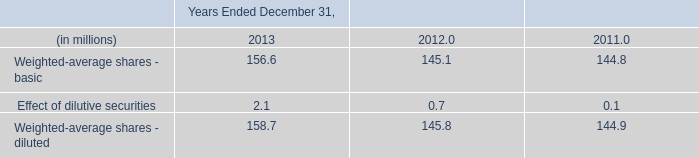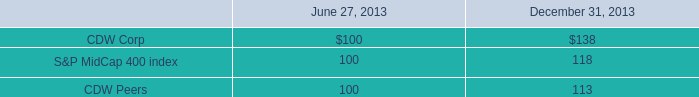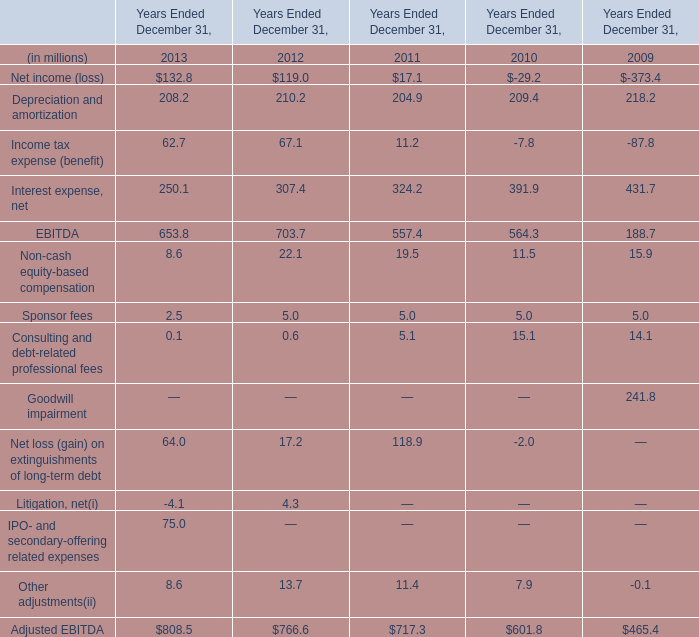When does Depreciation and amortization reach the largest value? 
Answer: 2009. 